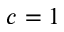Convert formula to latex. <formula><loc_0><loc_0><loc_500><loc_500>c = 1</formula> 